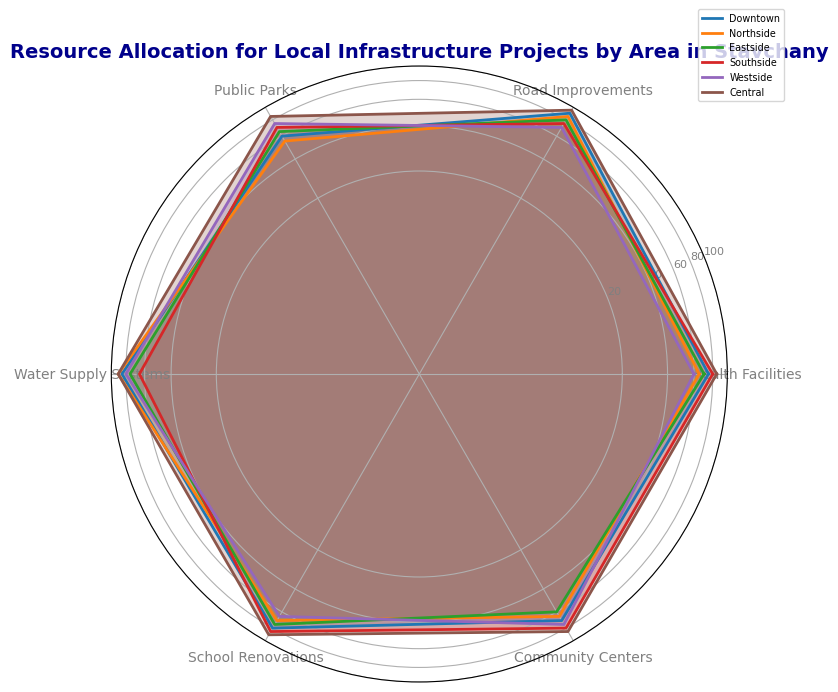Which area has the highest allocation for Community Centers? Look at the Community Centers axis, which is labeled on the radar chart. Identify the area whose line extends furthest out from the center along this axis.
Answer: Central Which area has the lowest combined allocation for Health Facilities and School Renovations? To answer this question, add the values for Health Facilities and School Renovations for each area and compare these sums. The sums are: Downtown (75+80=155), Northside (65+70=135), Eastside (70+75=145), Southside (80+85=165), Westside (60+65=125), Central (85+90=175).
Answer: Westside Does Southside have more resources allocated to Public Parks or Water Supply Systems? Compare the lengths of Southside’s segments on the axes for Public Parks and Water Supply Systems. The segment for Public Parks (70) is shorter than the segment for Water Supply Systems (65).
Answer: Public Parks What is the difference in allocation for Road Improvements between Central and Northside? Find the allocation values for Road Improvements for Central (95) and Northside (85). Subtract the smaller value from the larger one: 95 - 85 = 10.
Answer: 10 Which area has the most balanced allocation across all categories? The area with values closest together across all axes represents a more balanced allocation. By visually assessing the distances from the center to each point on the chart for each area, Central appears to have the most balanced allocation.
Answer: Central 